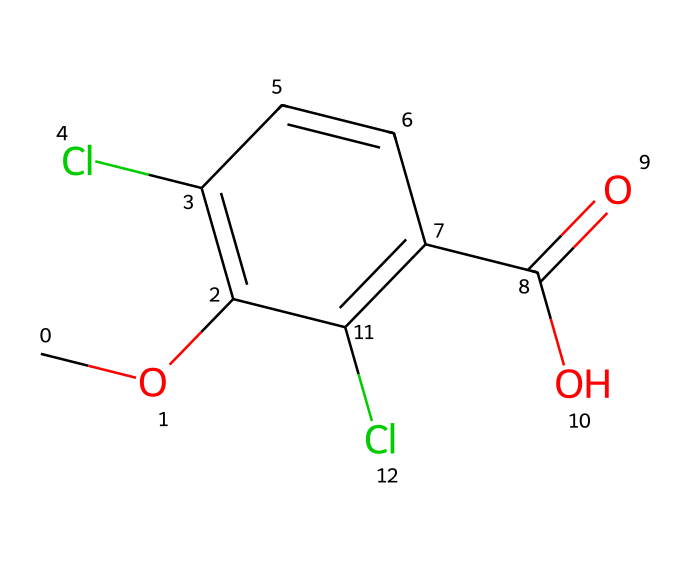How many chlorine atoms are present in dicamba? The structure shows two chlorine atoms attached to the aromatic ring, evidenced by the 'Cl' symbols in the SMILES representation.
Answer: two What is the functional group present in dicamba? The 'C(=O)O' part of the SMILES designates a carboxylic acid functional group, which is characteristic for dicamba's acidity and herbicidal action.
Answer: carboxylic acid What type of compound is dicamba classified as? Dicamba is an herbicide, which is a type of pesticide specifically designed for controlling undesired plants. The structural features support its classification.
Answer: herbicide How many carbon atoms are in dicamba? Counting from the SMILES representation, we find 10 carbon atoms represented in the structure, with both aromatic and aliphatic carbons included.
Answer: ten Which part of dicamba contributes to its herbicide efficacy? The presence of the carboxylic acid group is crucial, as it plays a key role in the herbicidal function through its interaction with plant growth regulators.
Answer: carboxylic acid group What is the molecular weight of dicamba? Calculating the molecular weight from the number and types of atoms present in the structure gives an approximate weight of 221.04 g/mol.
Answer: two hundred twenty-one point zero four 